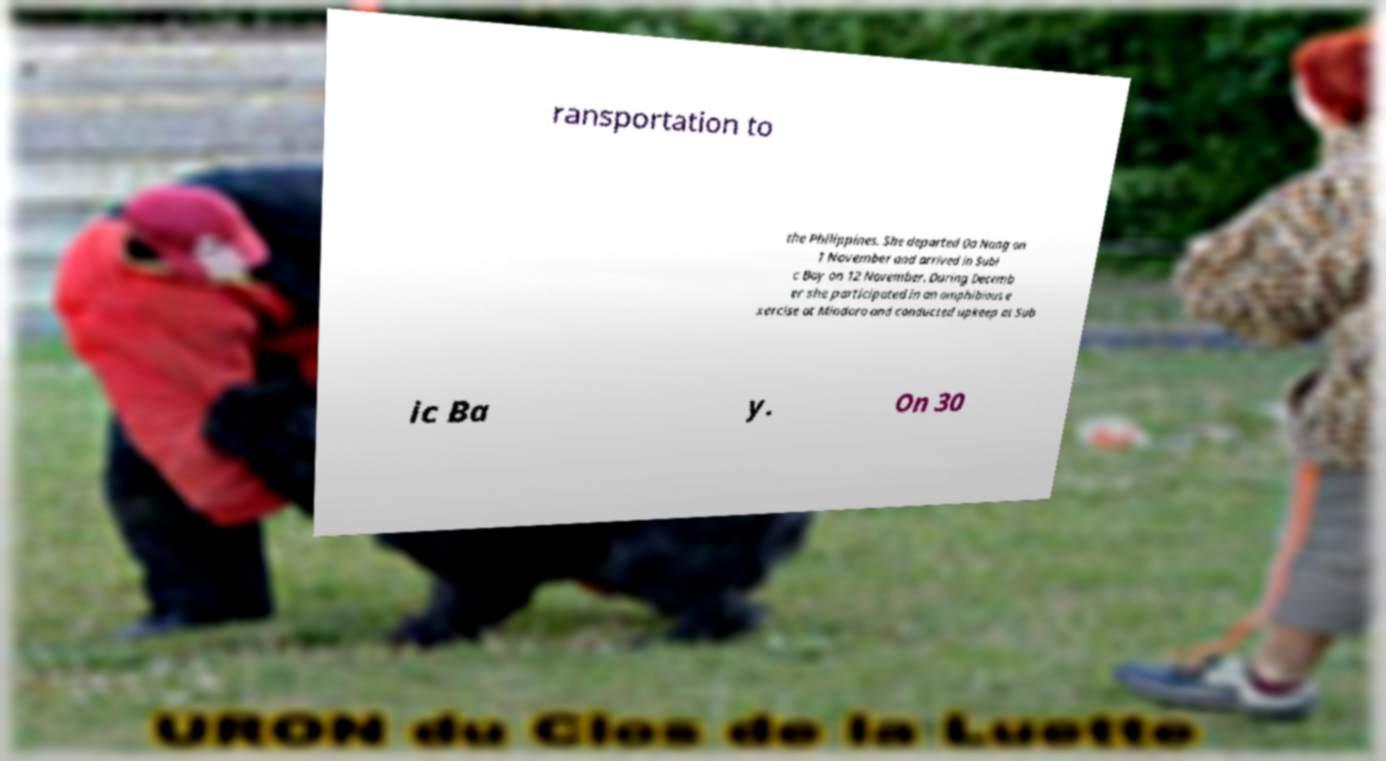Can you read and provide the text displayed in the image?This photo seems to have some interesting text. Can you extract and type it out for me? ransportation to the Philippines. She departed Da Nang on 1 November and arrived in Subi c Bay on 12 November. During Decemb er she participated in an amphibious e xercise at Mindoro and conducted upkeep at Sub ic Ba y. On 30 